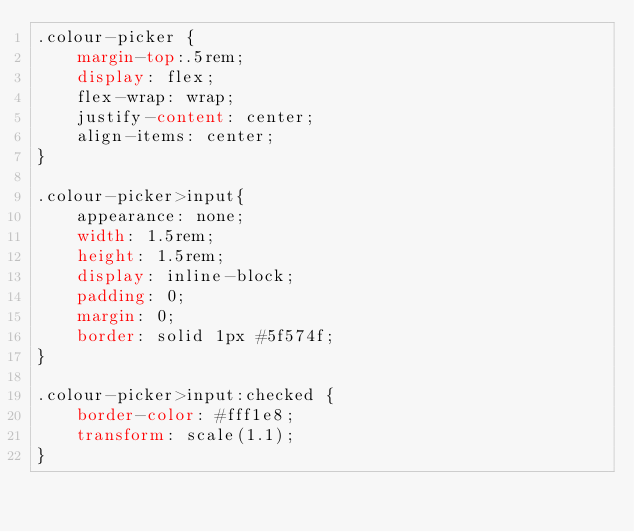<code> <loc_0><loc_0><loc_500><loc_500><_CSS_>.colour-picker {
	margin-top:.5rem;
	display: flex;
	flex-wrap: wrap;
	justify-content: center;
	align-items: center;
}

.colour-picker>input{
	appearance: none;
	width: 1.5rem;
	height: 1.5rem;
	display: inline-block;
	padding: 0;
	margin: 0;
	border: solid 1px #5f574f;
}

.colour-picker>input:checked {
	border-color: #fff1e8;
	transform: scale(1.1);
}
</code> 